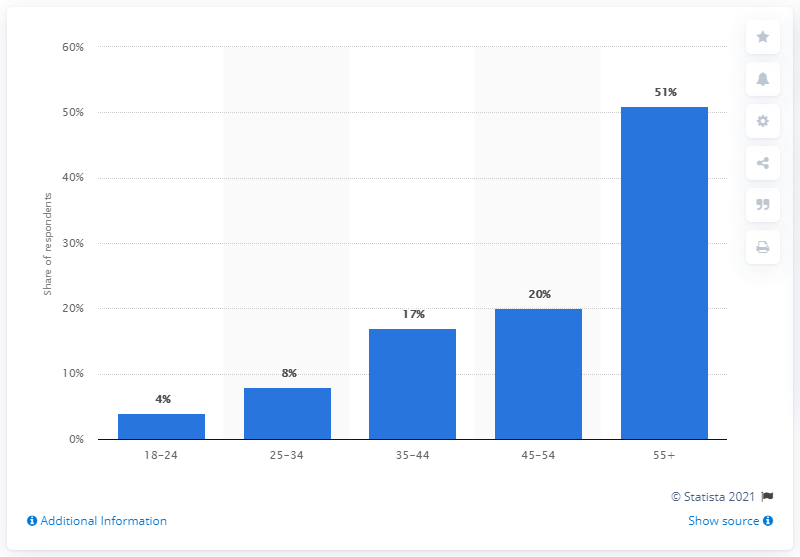List a handful of essential elements in this visual. The Nokia customers who were from the age group of 55 and above had the most customers. 